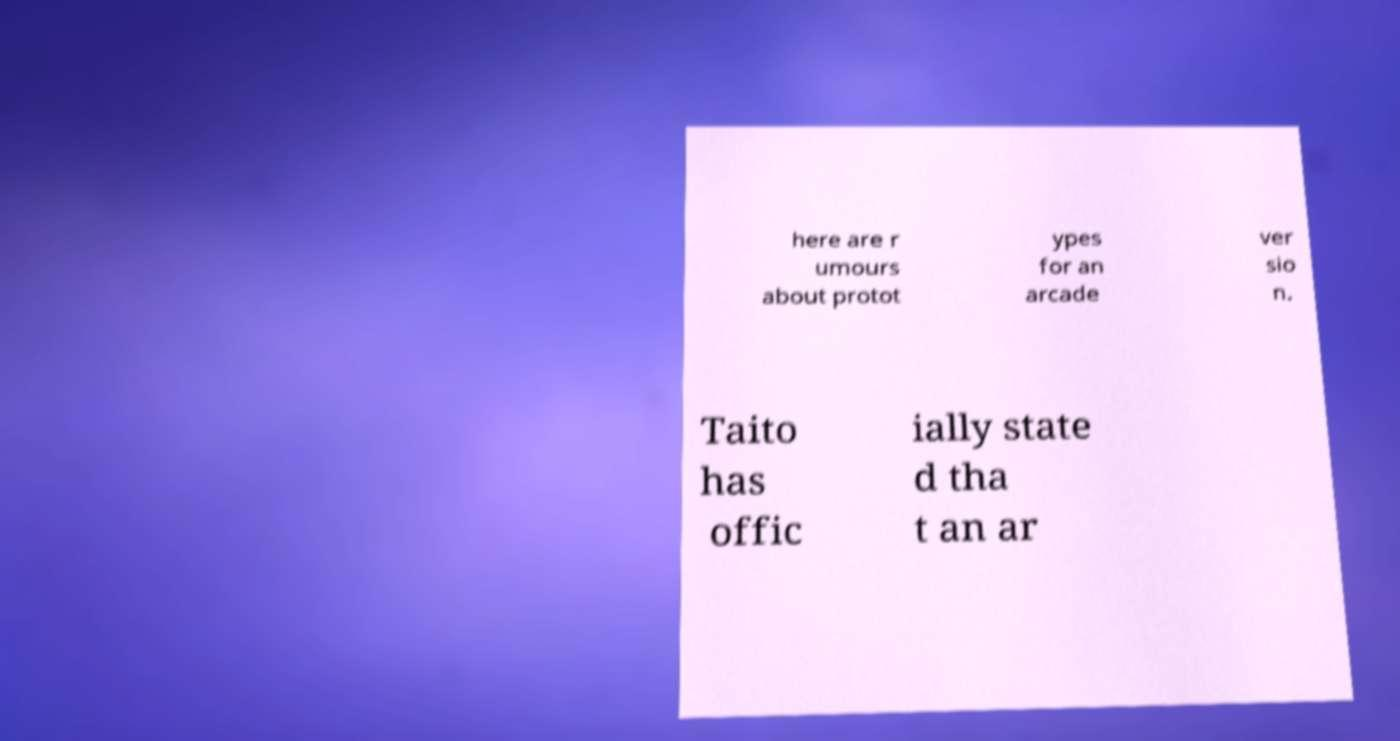Could you extract and type out the text from this image? here are r umours about protot ypes for an arcade ver sio n. Taito has offic ially state d tha t an ar 